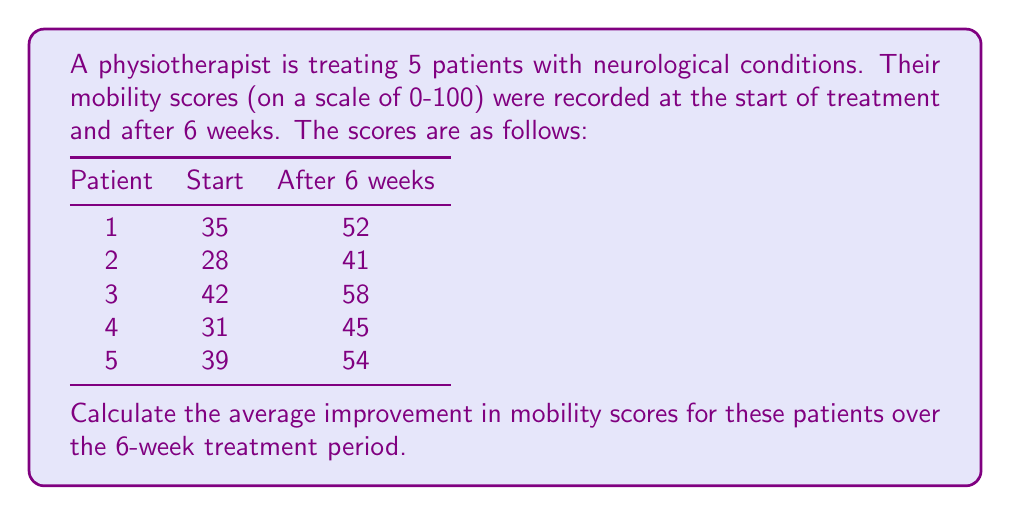Give your solution to this math problem. To solve this problem, we'll follow these steps:

1. Calculate the improvement for each patient:
   Patient 1: $52 - 35 = 17$
   Patient 2: $41 - 28 = 13$
   Patient 3: $58 - 42 = 16$
   Patient 4: $45 - 31 = 14$
   Patient 5: $54 - 39 = 15$

2. Sum up all the improvements:
   $17 + 13 + 16 + 14 + 15 = 75$

3. Calculate the average improvement by dividing the sum by the number of patients:
   $$\text{Average Improvement} = \frac{\text{Sum of Improvements}}{\text{Number of Patients}} = \frac{75}{5} = 15$$

Therefore, the average improvement in mobility scores for these patients over the 6-week treatment period is 15 points.
Answer: 15 points 